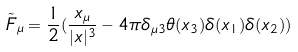<formula> <loc_0><loc_0><loc_500><loc_500>\tilde { F } _ { \mu } = \frac { 1 } { 2 } ( \frac { x _ { \mu } } { | x | ^ { 3 } } - 4 \pi \delta _ { \mu 3 } \theta ( x _ { 3 } ) \delta ( x _ { 1 } ) \delta ( x _ { 2 } ) )</formula> 